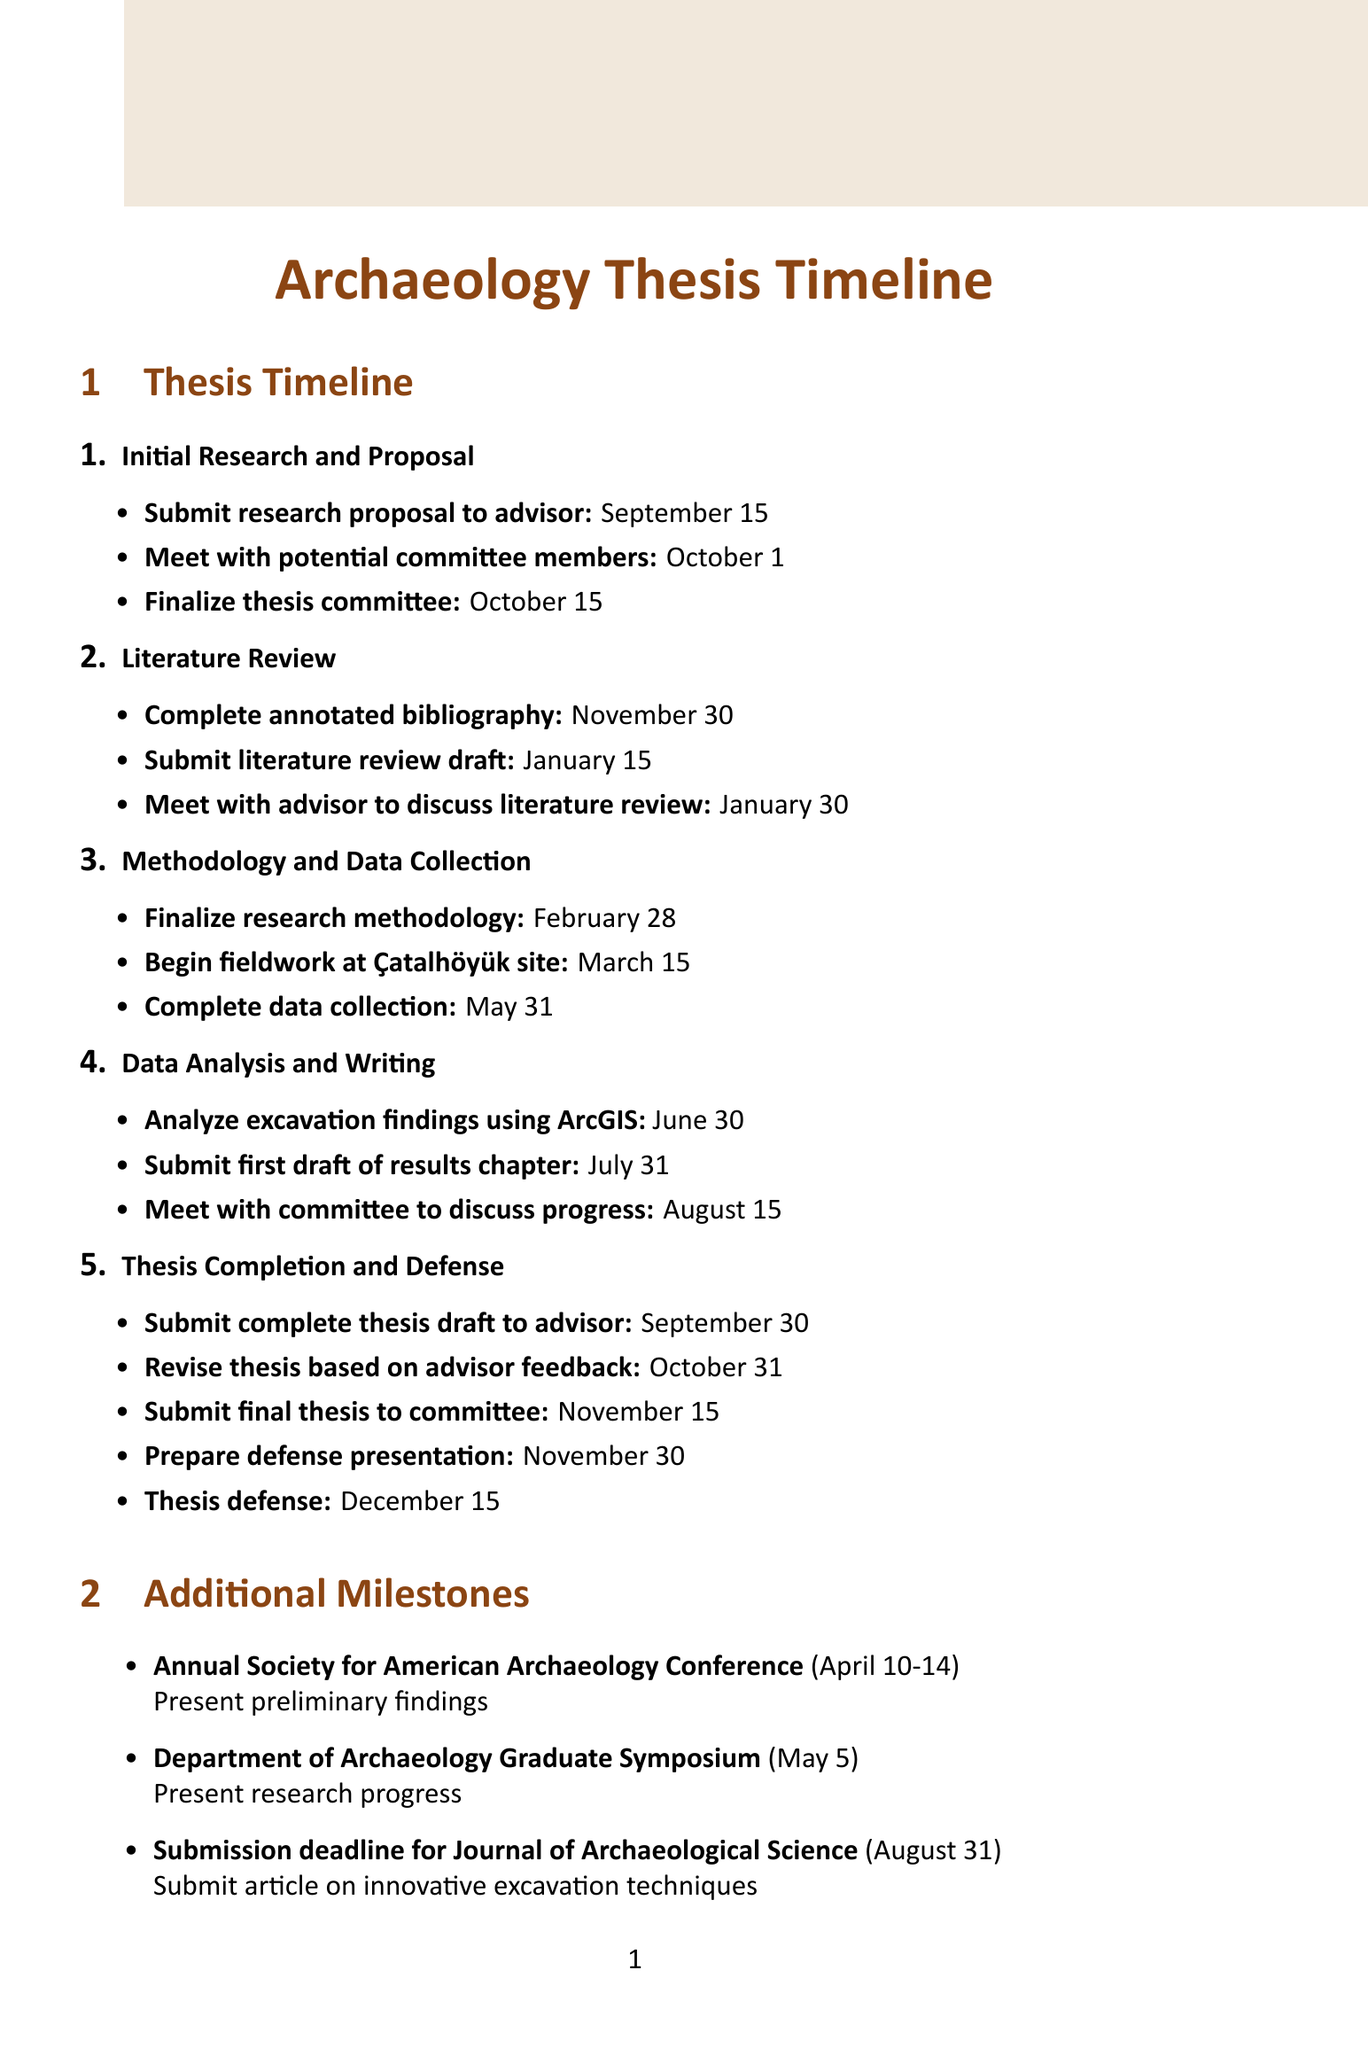what is the deadline for submitting the research proposal to the advisor? The deadline for submitting the research proposal is mentioned under the Initial Research and Proposal stage.
Answer: September 15 when is the literature review draft due? This date can be found in the Literature Review section of the timeline.
Answer: January 15 who is the thesis advisor? The thesis advisor is listed in the Committee Members section of the document.
Answer: Dr. Sarah Johnson what event is scheduled for April 10-14? The event and its date are noted in the Additional Milestones section of the document.
Answer: Annual Society for American Archaeology Conference how long do you have to complete data collection? This timeframe can be inferred by reviewing the deadlines listed in the Methodology and Data Collection stage.
Answer: March 15 to May 31 what is the final deadline for submitting the thesis to the committee? The final submission date is specified in the Thesis Completion and Defense section.
Answer: November 15 how many meetings are scheduled with the advisor during the Literature Review stage? This can be determined by counting the meeting entries listed in the Literature Review section.
Answer: 1 when should you prepare the defense presentation? The preparation time is highlighted in the Thesis Completion and Defense section of the timeline.
Answer: November 30 what software is available in the Digital Archaeology Lab? The available software is listed under Research Resources in the document.
Answer: ArcGIS, QGIS, AutoCAD 